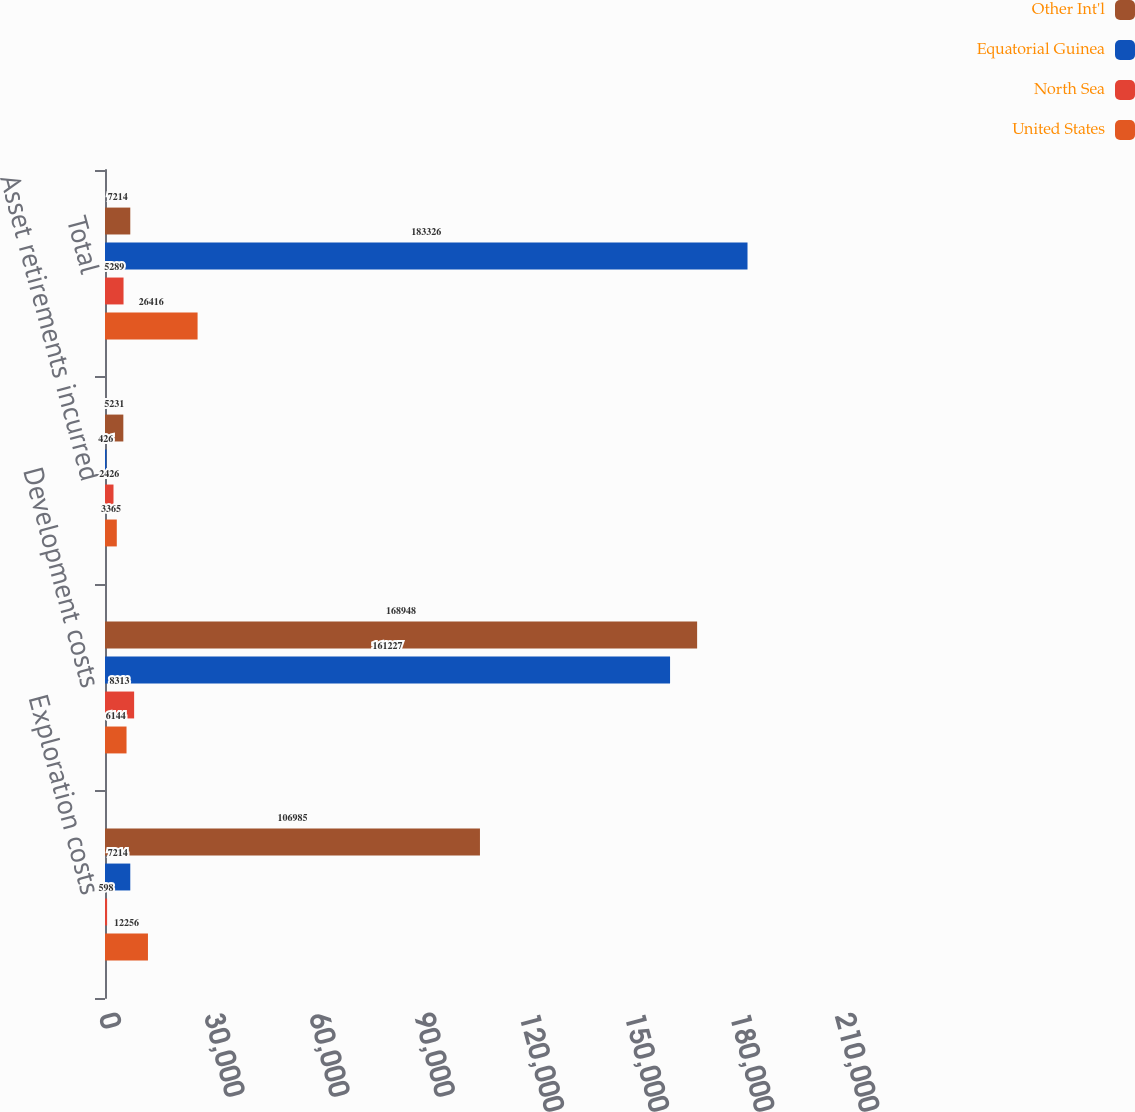<chart> <loc_0><loc_0><loc_500><loc_500><stacked_bar_chart><ecel><fcel>Exploration costs<fcel>Development costs<fcel>Asset retirements incurred<fcel>Total<nl><fcel>Other Int'l<fcel>106985<fcel>168948<fcel>5231<fcel>7214<nl><fcel>Equatorial Guinea<fcel>7214<fcel>161227<fcel>426<fcel>183326<nl><fcel>North Sea<fcel>598<fcel>8313<fcel>2426<fcel>5289<nl><fcel>United States<fcel>12256<fcel>6144<fcel>3365<fcel>26416<nl></chart> 